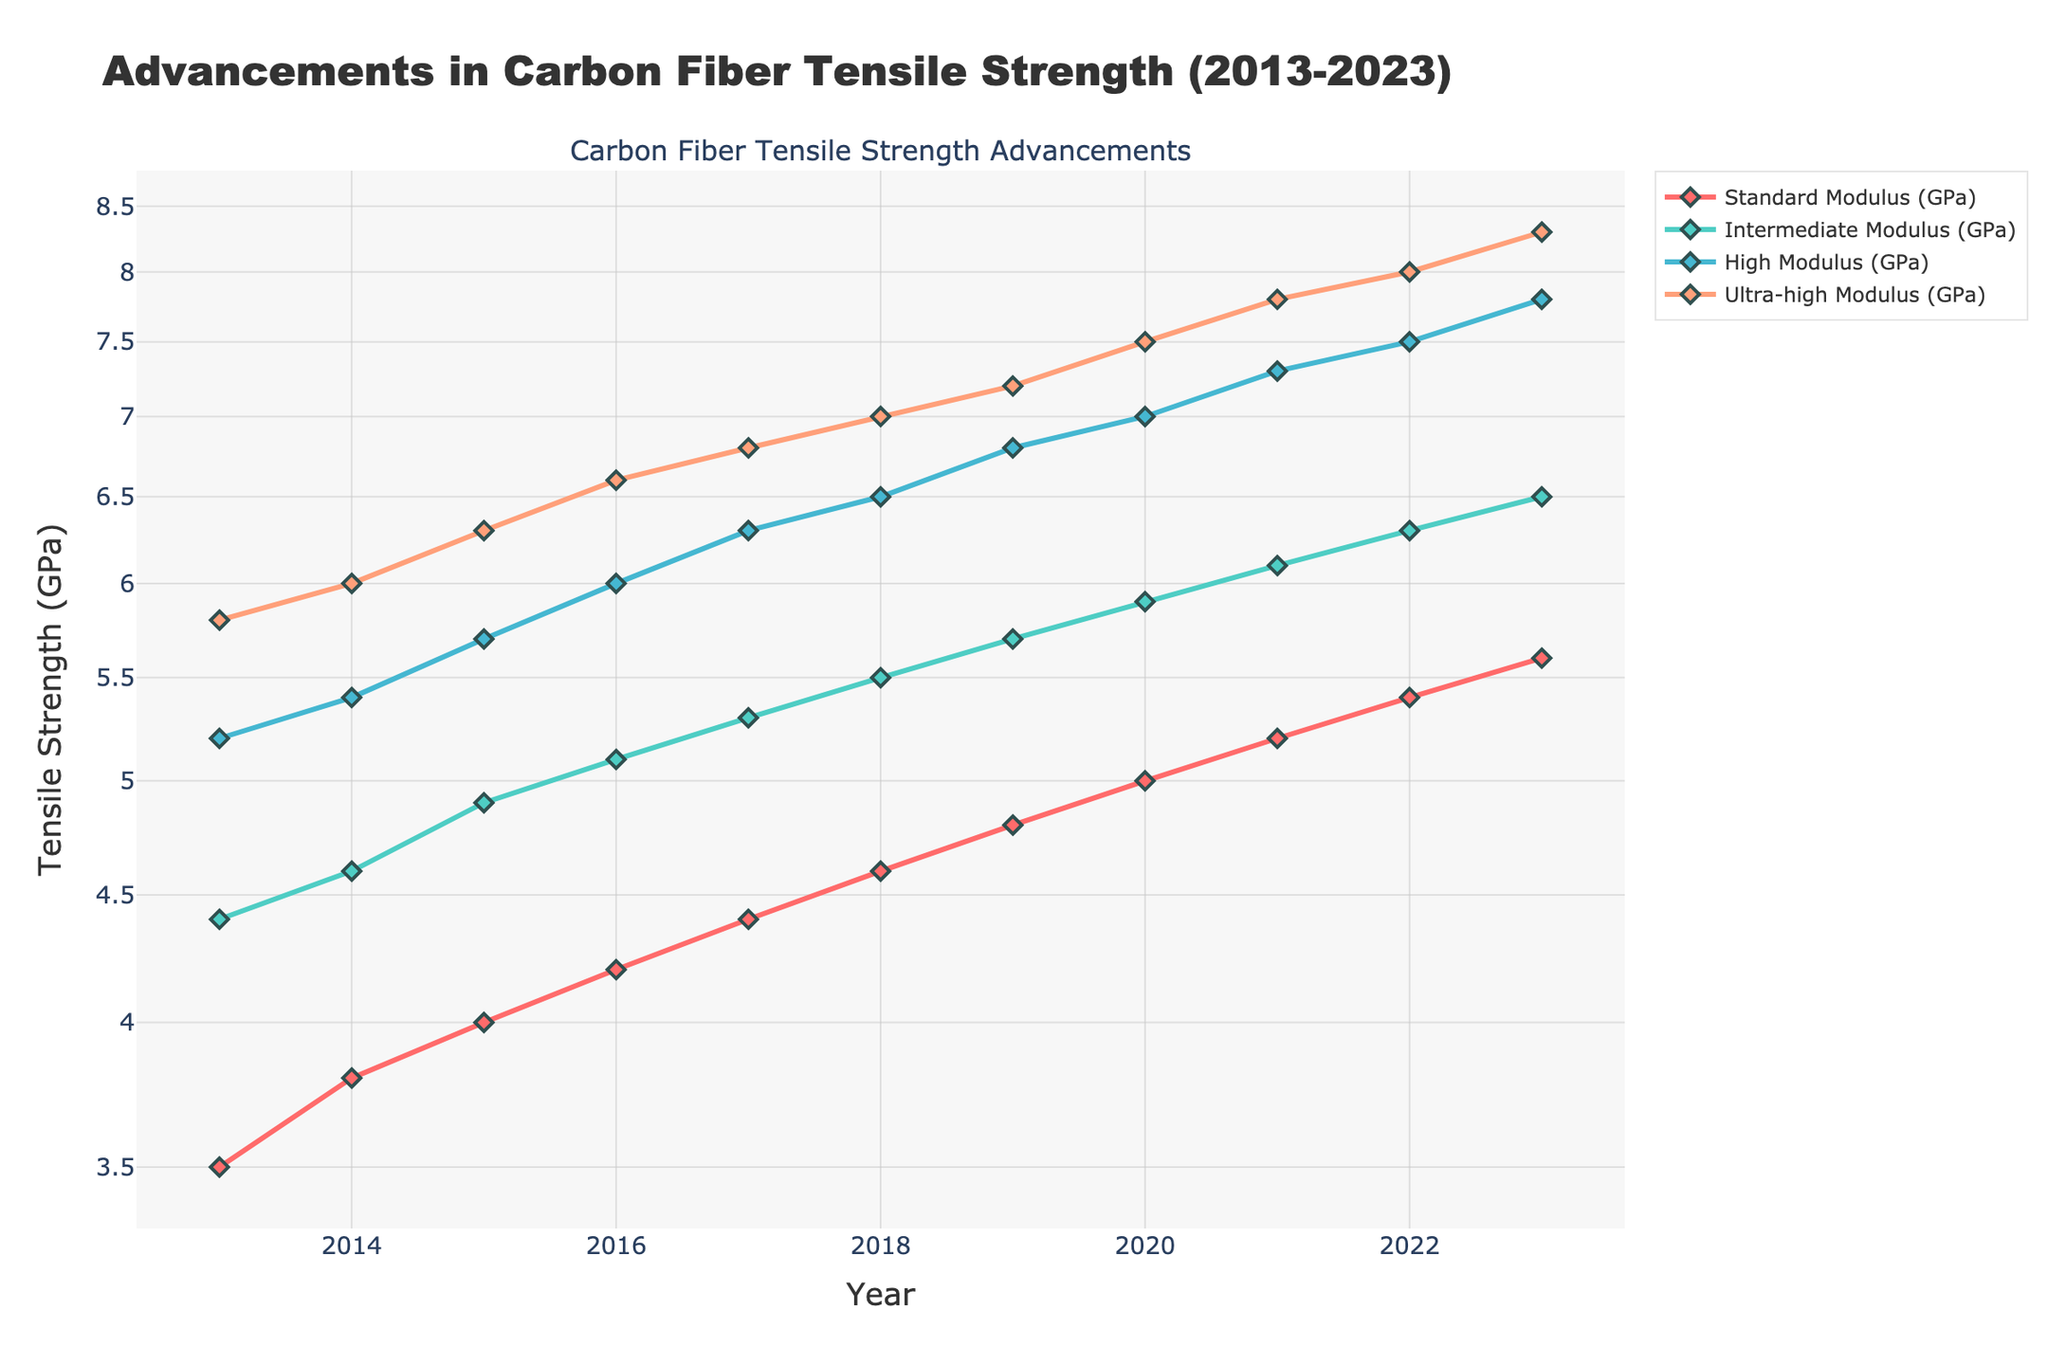What's the title of the figure? The title of the figure is usually found at the top of the figure and provides a brief description of what is being displayed. In this case, the title text reads "Advancements in Carbon Fiber Tensile Strength (2013-2023)".
Answer: Advancements in Carbon Fiber Tensile Strength (2013-2023) What are the four classifications of carbon fiber tensile strength shown in the plot? The labels for the classifications are usually listed in the legend, which distinguishes different line colors and styles. Here, the classifications are Standard Modulus (GPa), Intermediate Modulus (GPa), High Modulus (GPa), and Ultra-high Modulus (GPa).
Answer: Standard Modulus (GPa), Intermediate Modulus (GPa), High Modulus (GPa), Ultra-high Modulus (GPa) Which classification has the highest tensile strength in 2023? By looking at the endpoint of each line plot for the year 2023, we see that the Ultra-high Modulus line is the highest, indicating it has the highest tensile strength.
Answer: Ultra-high Modulus (GPa) How has the tensile strength of Intermediate Modulus carbon fiber changed from 2015 to 2020? To determine the change, subtract the tensile strength value for 2015 from that of 2020 for Intermediate Modulus. From the data, 5.9 GPa - 4.9 GPa = 1.0 GPa.
Answer: Increased by 1.0 GPa What is the average tensile strength of High Modulus carbon fiber over the past decade? Calculate the average by summing the yearly tensile strength values for High Modulus from 2013 to 2023 and dividing by the number of years. Sum = 5.2 + 5.4 + 5.7 + 6.0 + 6.3 + 6.5 + 6.8 + 7.0 + 7.3 + 7.5 + 7.8 = 70.5 GPa; Average = 70.5/11 ≈ 6.41 GPa.
Answer: 6.41 GPa By how much did the tensile strength of Standard Modulus carbon fiber increase between 2013 and 2023? To find the increase, subtract the tensile strength of 2013 from that of 2023 for Standard Modulus. From the data, 5.6 GPa - 3.5 GPa = 2.1 GPa.
Answer: Increased by 2.1 GPa Which classification shows the largest growth rate in tensile strength over the decade? The growth rate for each classification can be determined by considering the ratio of tensile strength from 2023 to 2013. Ultra-high Modulus has the largest growth rate (8.3 GPa in 2023 vs. 5.8 GPa in 2013), providing a growth ratio of 8.3/5.8 ≈ 1.43.
Answer: Ultra-high Modulus How do the trends differ between Standard Modulus and High Modulus over the decade? Visually analyze the slopes of the two lines: Standard Modulus line shows a steady increase, while High Modulus shows a steeper increase, indicating a quicker rate of tensile strength improvement.
Answer: High Modulus had a steeper increase What are the general shapes of the trends for all classifications? All the lines follow a generally upward trend across the years, reflecting a continuous improvement in tensile strength for all classifications.
Answer: Upward trends 